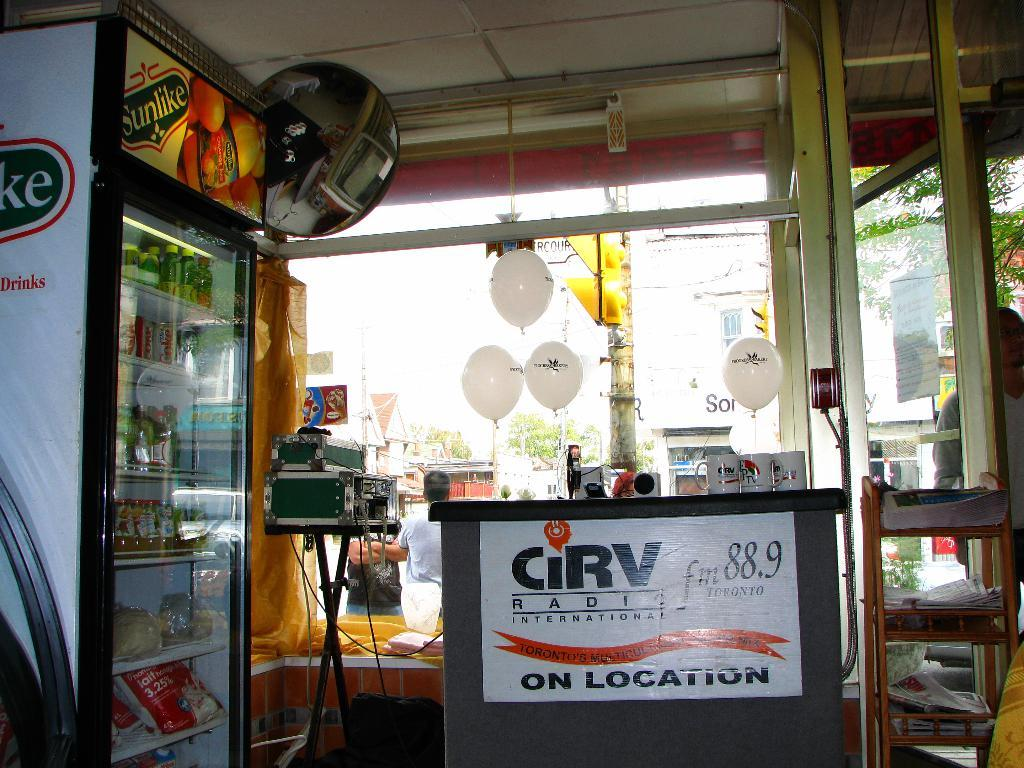<image>
Write a terse but informative summary of the picture. the inside of a buliding with a podium that has a poster on it that says 'on location' 